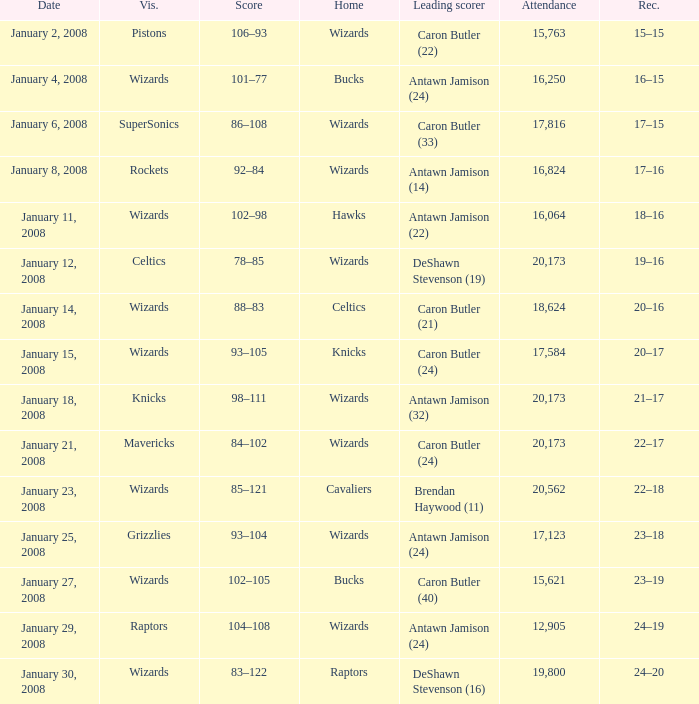How many people were in attendance on January 4, 2008? 16250.0. 